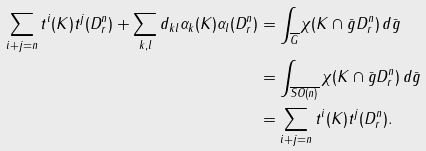Convert formula to latex. <formula><loc_0><loc_0><loc_500><loc_500>\sum _ { i + j = n } t ^ { i } ( K ) t ^ { j } ( D ^ { n } _ { r } ) + \sum _ { k , l } d _ { k l } \alpha _ { k } ( K ) \alpha _ { l } ( D ^ { n } _ { r } ) & = \int _ { \overline { G } } \chi ( K \cap \bar { g } D ^ { n } _ { r } ) \, d \bar { g } \\ & = \int _ { \overline { S O ( n ) } } \chi ( K \cap \bar { g } D ^ { n } _ { r } ) \, d \bar { g } \\ & = \sum _ { i + j = n } t ^ { i } ( K ) t ^ { j } ( D ^ { n } _ { r } ) .</formula> 